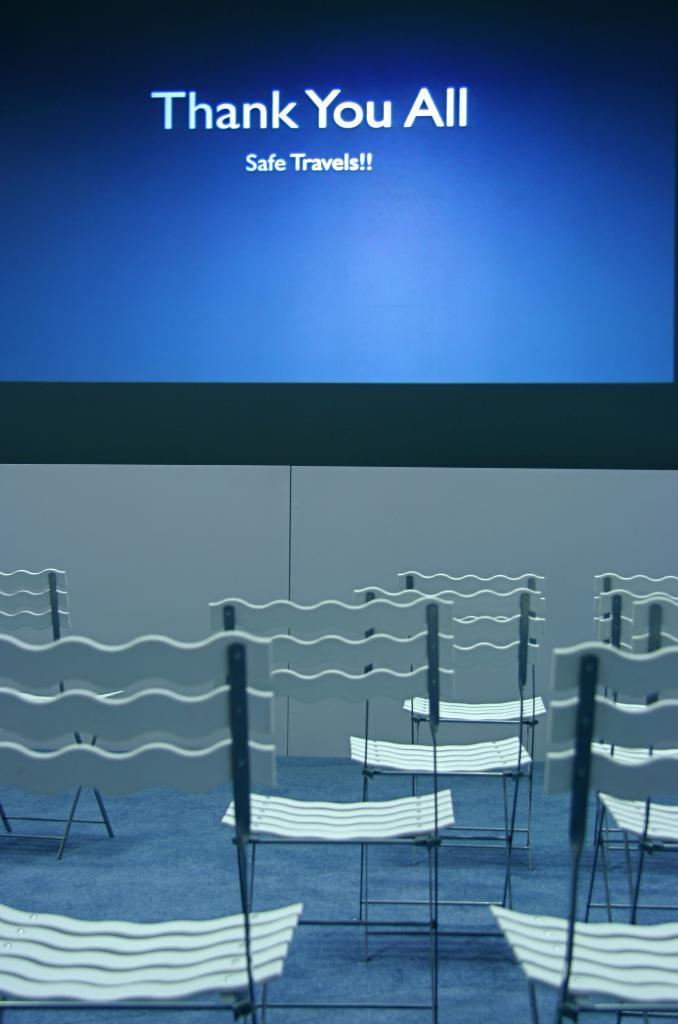How would you summarize this image in a sentence or two? In this image we can see a screen with some text in it, there we can also see few chairs and a floor mat. 